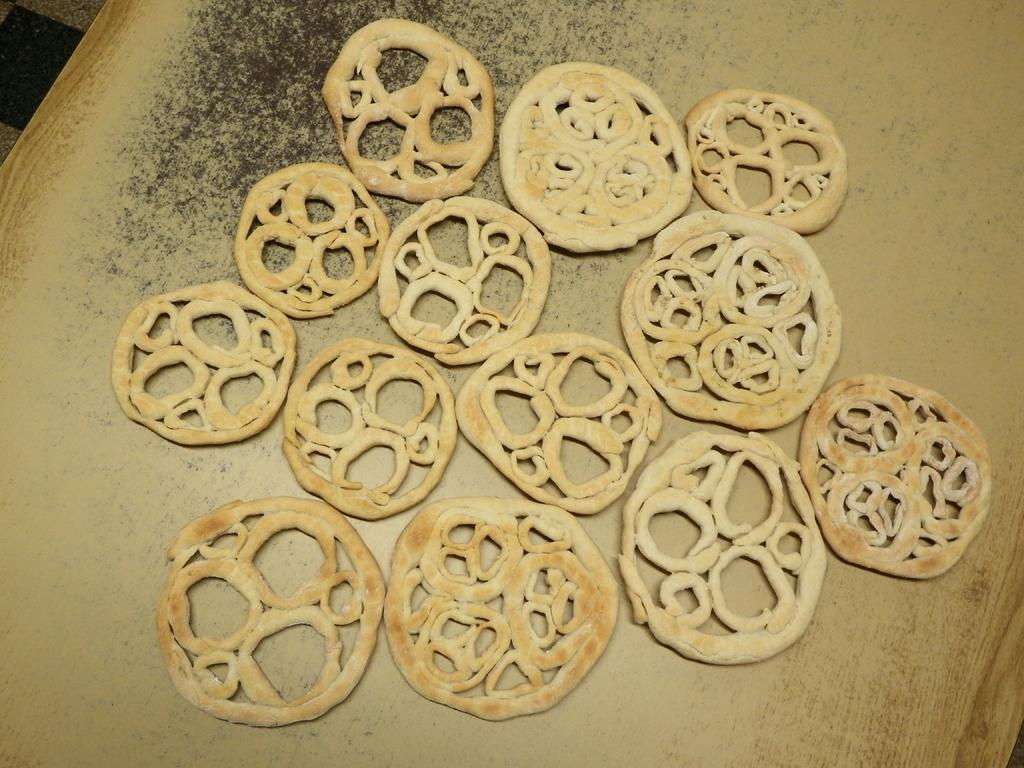Could you give a brief overview of what you see in this image? In the center of the image there is a table. On the table we can see some food items are there. 